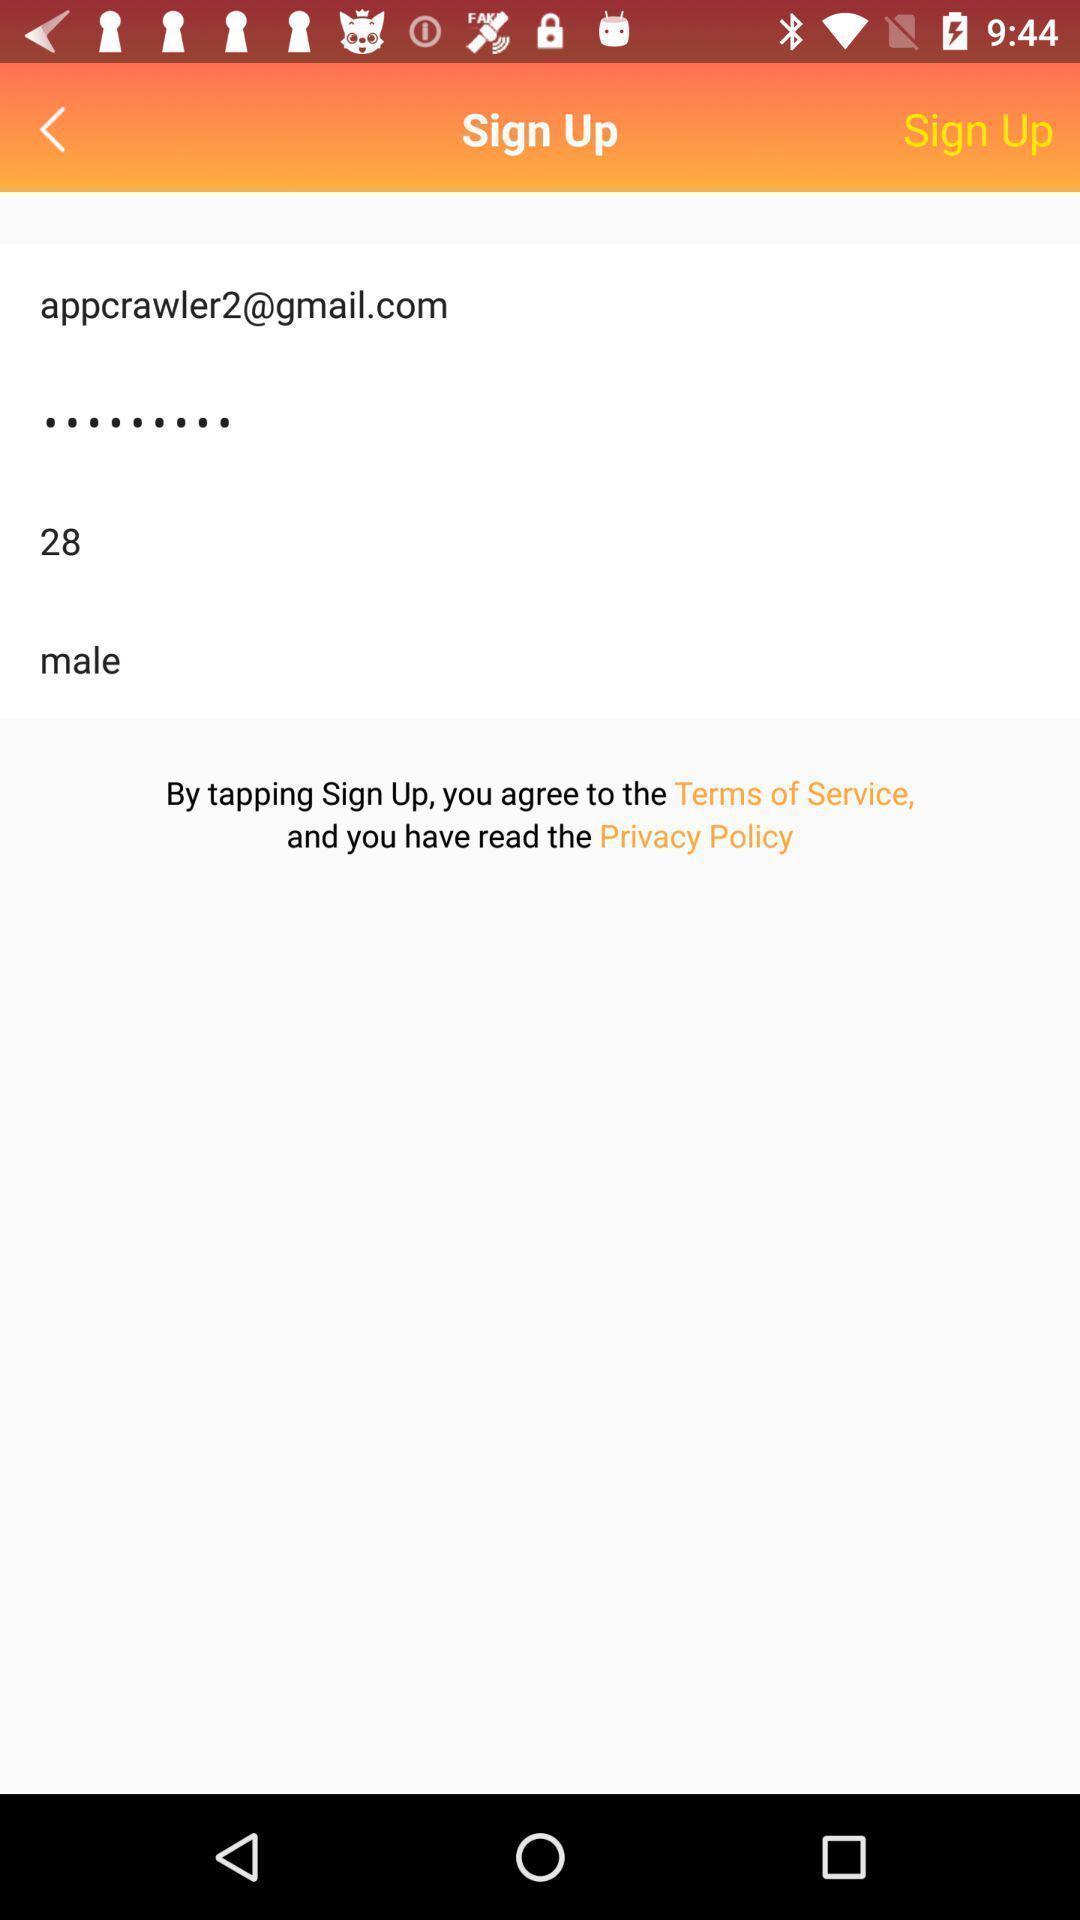Provide a description of this screenshot. Sign up page with personal information and login credentials. 